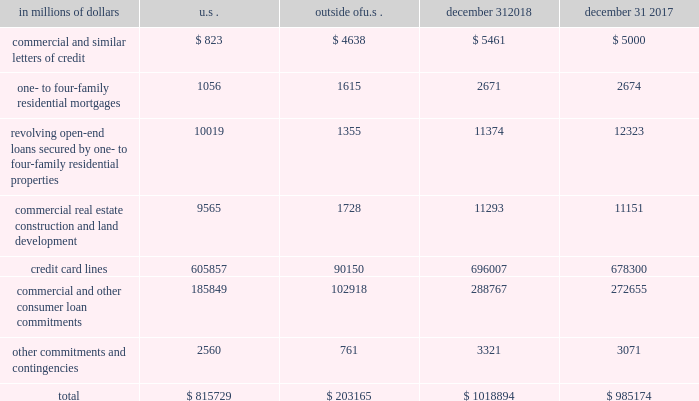Credit commitments and lines of credit the table below summarizes citigroup 2019s credit commitments : in millions of dollars u.s .
Outside of u.s .
December 31 , december 31 .
The majority of unused commitments are contingent upon customers maintaining specific credit standards .
Commercial commitments generally have floating interest rates and fixed expiration dates and may require payment of fees .
Such fees ( net of certain direct costs ) are deferred and , upon exercise of the commitment , amortized over the life of the loan or , if exercise is deemed remote , amortized over the commitment period .
Commercial and similar letters of credit a commercial letter of credit is an instrument by which citigroup substitutes its credit for that of a customer to enable the customer to finance the purchase of goods or to incur other commitments .
Citigroup issues a letter on behalf of its client to a supplier and agrees to pay the supplier upon presentation of documentary evidence that the supplier has performed in accordance with the terms of the letter of credit .
When a letter of credit is drawn , the customer is then required to reimburse citigroup .
One- to four-family residential mortgages a one- to four-family residential mortgage commitment is a written confirmation from citigroup to a seller of a property that the bank will advance the specified sums enabling the buyer to complete the purchase .
Revolving open-end loans secured by one- to four-family residential properties revolving open-end loans secured by one- to four-family residential properties are essentially home equity lines of credit .
A home equity line of credit is a loan secured by a primary residence or second home to the extent of the excess of fair market value over the debt outstanding for the first mortgage .
Commercial real estate , construction and land development commercial real estate , construction and land development include unused portions of commitments to extend credit for the purpose of financing commercial and multifamily residential properties as well as land development projects .
Both secured-by-real-estate and unsecured commitments are included in this line , as well as undistributed loan proceeds , where there is an obligation to advance for construction progress payments .
However , this line only includes those extensions of credit that , once funded , will be classified as total loans , net on the consolidated balance sheet .
Credit card lines citigroup provides credit to customers by issuing credit cards .
The credit card lines are cancelable by providing notice to the cardholder or without such notice as permitted by local law .
Commercial and other consumer loan commitments commercial and other consumer loan commitments include overdraft and liquidity facilities as well as commercial commitments to make or purchase loans , purchase third-party receivables , provide note issuance or revolving underwriting facilities and invest in the form of equity .
Other commitments and contingencies other commitments and contingencies include committed or unsettled regular-way reverse repurchase agreements and all other transactions related to commitments and contingencies not reported on the lines above .
Unsettled reverse repurchase and securities lending agreements and unsettled repurchase and securities borrowing agreements in addition , in the normal course of business , citigroup enters into reverse repurchase and securities borrowing agreements , as well as repurchase and securities lending agreements , which settle at a future date .
At december 31 , 2018 , and 2017 , citigroup had $ 36.1 billion and $ 35.0 billion unsettled reverse repurchase and securities borrowing agreements , respectively , and $ 30.7 billion and $ 19.1 billion unsettled repurchase and securities lending agreements , respectively .
For a further discussion of securities purchased under agreements to resell and securities borrowed , and securities sold under agreements to repurchase and securities loaned , including the company 2019s policy for offsetting repurchase and reverse repurchase agreements , see note 11 to the consolidated financial statements. .
What percentage of total credit commitments as of december 31 , 2017 are credit card lines? 
Computations: (678300 / 985174)
Answer: 0.68851. 